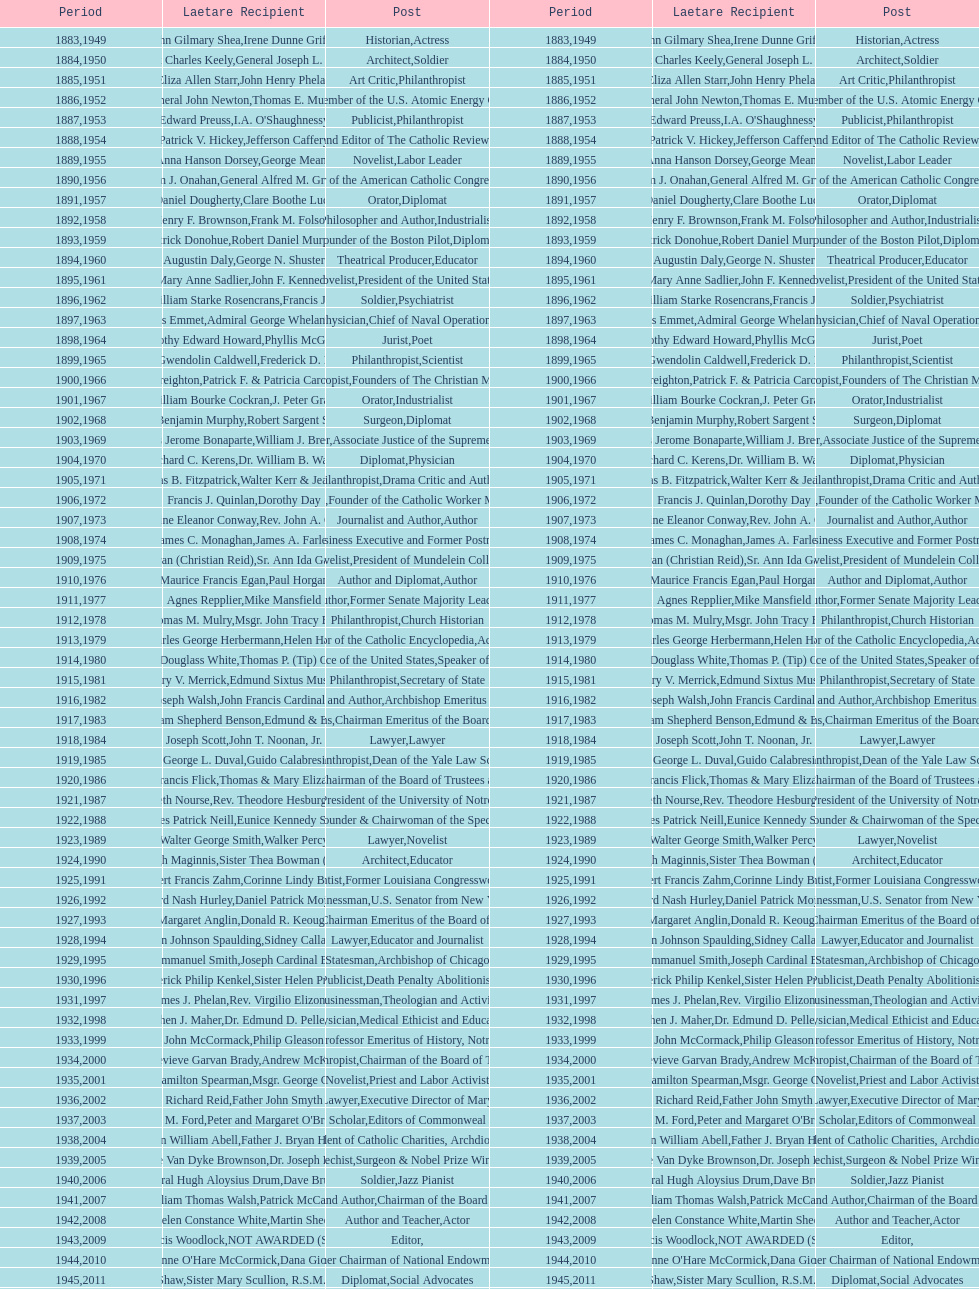Who has won this medal and the nobel prize as well? Dr. Joseph E. Murray. I'm looking to parse the entire table for insights. Could you assist me with that? {'header': ['Period', 'Laetare Recipient', 'Post', 'Period', 'Laetare Recipient', 'Post'], 'rows': [['1883', 'John Gilmary Shea', 'Historian', '1949', 'Irene Dunne Griffin', 'Actress'], ['1884', 'Patrick Charles Keely', 'Architect', '1950', 'General Joseph L. Collins', 'Soldier'], ['1885', 'Eliza Allen Starr', 'Art Critic', '1951', 'John Henry Phelan', 'Philanthropist'], ['1886', 'General John Newton', 'Engineer', '1952', 'Thomas E. Murray', 'Member of the U.S. Atomic Energy Commission'], ['1887', 'Edward Preuss', 'Publicist', '1953', "I.A. O'Shaughnessy", 'Philanthropist'], ['1888', 'Patrick V. Hickey', 'Founder and Editor of The Catholic Review', '1954', 'Jefferson Caffery', 'Diplomat'], ['1889', 'Anna Hanson Dorsey', 'Novelist', '1955', 'George Meany', 'Labor Leader'], ['1890', 'William J. Onahan', 'Organizer of the American Catholic Congress', '1956', 'General Alfred M. Gruenther', 'Soldier'], ['1891', 'Daniel Dougherty', 'Orator', '1957', 'Clare Boothe Luce', 'Diplomat'], ['1892', 'Henry F. Brownson', 'Philosopher and Author', '1958', 'Frank M. Folsom', 'Industrialist'], ['1893', 'Patrick Donohue', 'Founder of the Boston Pilot', '1959', 'Robert Daniel Murphy', 'Diplomat'], ['1894', 'Augustin Daly', 'Theatrical Producer', '1960', 'George N. Shuster', 'Educator'], ['1895', 'Mary Anne Sadlier', 'Novelist', '1961', 'John F. Kennedy', 'President of the United States'], ['1896', 'General William Starke Rosencrans', 'Soldier', '1962', 'Francis J. Braceland', 'Psychiatrist'], ['1897', 'Thomas Addis Emmet', 'Physician', '1963', 'Admiral George Whelan Anderson, Jr.', 'Chief of Naval Operations'], ['1898', 'Timothy Edward Howard', 'Jurist', '1964', 'Phyllis McGinley', 'Poet'], ['1899', 'Mary Gwendolin Caldwell', 'Philanthropist', '1965', 'Frederick D. Rossini', 'Scientist'], ['1900', 'John A. Creighton', 'Philanthropist', '1966', 'Patrick F. & Patricia Caron Crowley', 'Founders of The Christian Movement'], ['1901', 'William Bourke Cockran', 'Orator', '1967', 'J. Peter Grace', 'Industrialist'], ['1902', 'John Benjamin Murphy', 'Surgeon', '1968', 'Robert Sargent Shriver', 'Diplomat'], ['1903', 'Charles Jerome Bonaparte', 'Lawyer', '1969', 'William J. Brennan Jr.', 'Associate Justice of the Supreme Court'], ['1904', 'Richard C. Kerens', 'Diplomat', '1970', 'Dr. William B. Walsh', 'Physician'], ['1905', 'Thomas B. Fitzpatrick', 'Philanthropist', '1971', 'Walter Kerr & Jean Kerr', 'Drama Critic and Author'], ['1906', 'Francis J. Quinlan', 'Physician', '1972', 'Dorothy Day', 'Founder of the Catholic Worker Movement'], ['1907', 'Katherine Eleanor Conway', 'Journalist and Author', '1973', "Rev. John A. O'Brien", 'Author'], ['1908', 'James C. Monaghan', 'Economist', '1974', 'James A. Farley', 'Business Executive and Former Postmaster General'], ['1909', 'Frances Tieran (Christian Reid)', 'Novelist', '1975', 'Sr. Ann Ida Gannon, BMV', 'President of Mundelein College'], ['1910', 'Maurice Francis Egan', 'Author and Diplomat', '1976', 'Paul Horgan', 'Author'], ['1911', 'Agnes Repplier', 'Author', '1977', 'Mike Mansfield', 'Former Senate Majority Leader'], ['1912', 'Thomas M. Mulry', 'Philanthropist', '1978', 'Msgr. John Tracy Ellis', 'Church Historian'], ['1913', 'Charles George Herbermann', 'Editor of the Catholic Encyclopedia', '1979', 'Helen Hayes', 'Actress'], ['1914', 'Edward Douglass White', 'Chief Justice of the United States', '1980', "Thomas P. (Tip) O'Neill Jr.", 'Speaker of the House'], ['1915', 'Mary V. Merrick', 'Philanthropist', '1981', 'Edmund Sixtus Muskie', 'Secretary of State'], ['1916', 'James Joseph Walsh', 'Physician and Author', '1982', 'John Francis Cardinal Dearden', 'Archbishop Emeritus of Detroit'], ['1917', 'Admiral William Shepherd Benson', 'Chief of Naval Operations', '1983', 'Edmund & Evelyn Stephan', 'Chairman Emeritus of the Board of Trustees and his wife'], ['1918', 'Joseph Scott', 'Lawyer', '1984', 'John T. Noonan, Jr.', 'Lawyer'], ['1919', 'George L. Duval', 'Philanthropist', '1985', 'Guido Calabresi', 'Dean of the Yale Law School'], ['1920', 'Lawrence Francis Flick', 'Physician', '1986', 'Thomas & Mary Elizabeth Carney', 'Chairman of the Board of Trustees and his wife'], ['1921', 'Elizabeth Nourse', 'Artist', '1987', 'Rev. Theodore Hesburgh, CSC', 'President of the University of Notre Dame'], ['1922', 'Charles Patrick Neill', 'Economist', '1988', 'Eunice Kennedy Shriver', 'Founder & Chairwoman of the Special Olympics'], ['1923', 'Walter George Smith', 'Lawyer', '1989', 'Walker Percy', 'Novelist'], ['1924', 'Charles Donagh Maginnis', 'Architect', '1990', 'Sister Thea Bowman (posthumously)', 'Educator'], ['1925', 'Albert Francis Zahm', 'Scientist', '1991', 'Corinne Lindy Boggs', 'Former Louisiana Congresswoman'], ['1926', 'Edward Nash Hurley', 'Businessman', '1992', 'Daniel Patrick Moynihan', 'U.S. Senator from New York'], ['1927', 'Margaret Anglin', 'Actress', '1993', 'Donald R. Keough', 'Chairman Emeritus of the Board of Trustees'], ['1928', 'John Johnson Spaulding', 'Lawyer', '1994', 'Sidney Callahan', 'Educator and Journalist'], ['1929', 'Alfred Emmanuel Smith', 'Statesman', '1995', 'Joseph Cardinal Bernardin', 'Archbishop of Chicago'], ['1930', 'Frederick Philip Kenkel', 'Publicist', '1996', 'Sister Helen Prejean', 'Death Penalty Abolitionist'], ['1931', 'James J. Phelan', 'Businessman', '1997', 'Rev. Virgilio Elizondo', 'Theologian and Activist'], ['1932', 'Stephen J. Maher', 'Physician', '1998', 'Dr. Edmund D. Pellegrino', 'Medical Ethicist and Educator'], ['1933', 'John McCormack', 'Artist', '1999', 'Philip Gleason', 'Professor Emeritus of History, Notre Dame'], ['1934', 'Genevieve Garvan Brady', 'Philanthropist', '2000', 'Andrew McKenna', 'Chairman of the Board of Trustees'], ['1935', 'Francis Hamilton Spearman', 'Novelist', '2001', 'Msgr. George G. Higgins', 'Priest and Labor Activist'], ['1936', 'Richard Reid', 'Journalist and Lawyer', '2002', 'Father John Smyth', 'Executive Director of Maryville Academy'], ['1937', 'Jeremiah D. M. Ford', 'Scholar', '2003', "Peter and Margaret O'Brien Steinfels", 'Editors of Commonweal'], ['1938', 'Irvin William Abell', 'Surgeon', '2004', 'Father J. Bryan Hehir', 'President of Catholic Charities, Archdiocese of Boston'], ['1939', 'Josephine Van Dyke Brownson', 'Catechist', '2005', 'Dr. Joseph E. Murray', 'Surgeon & Nobel Prize Winner'], ['1940', 'General Hugh Aloysius Drum', 'Soldier', '2006', 'Dave Brubeck', 'Jazz Pianist'], ['1941', 'William Thomas Walsh', 'Journalist and Author', '2007', 'Patrick McCartan', 'Chairman of the Board of Trustees'], ['1942', 'Helen Constance White', 'Author and Teacher', '2008', 'Martin Sheen', 'Actor'], ['1943', 'Thomas Francis Woodlock', 'Editor', '2009', 'NOT AWARDED (SEE BELOW)', ''], ['1944', "Anne O'Hare McCormick", 'Journalist', '2010', 'Dana Gioia', 'Former Chairman of National Endowment for the Arts'], ['1945', 'Gardiner Howland Shaw', 'Diplomat', '2011', 'Sister Mary Scullion, R.S.M., & Joan McConnon', 'Social Advocates'], ['1946', 'Carlton J. H. Hayes', 'Historian and Diplomat', '2012', 'Ken Hackett', 'Former President of Catholic Relief Services'], ['1947', 'William G. Bruce', 'Publisher and Civic Leader', '2013', 'Sister Susanne Gallagher, S.P.\\nSister Mary Therese Harrington, S.H.\\nRev. James H. McCarthy', 'Founders of S.P.R.E.D. (Special Religious Education Development Network)'], ['1948', 'Frank C. Walker', 'Postmaster General and Civic Leader', '2014', 'Kenneth R. Miller', 'Professor of Biology at Brown University']]} 